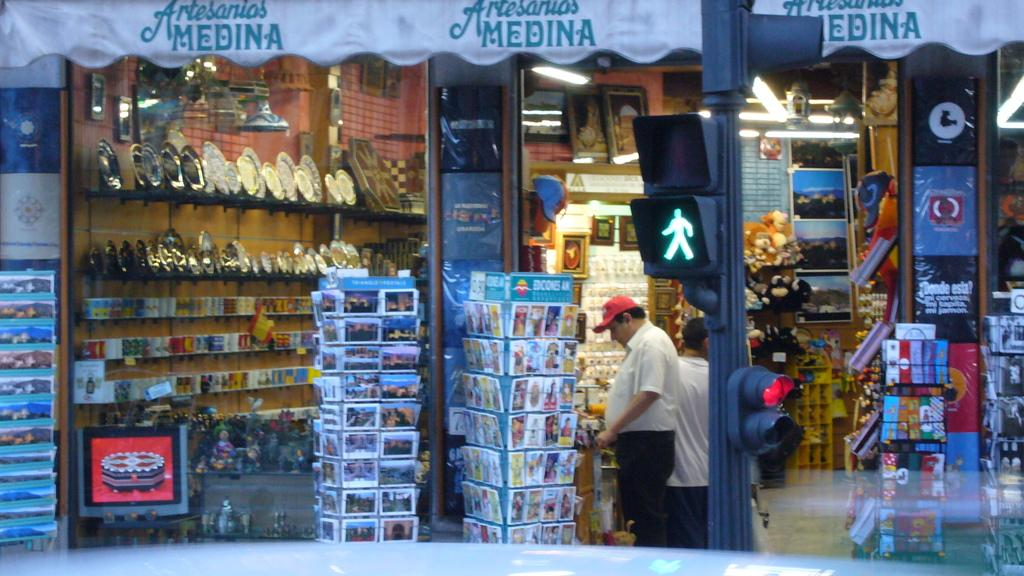<image>
Render a clear and concise summary of the photo. A store has a canopy with the word MEDINA on it. 